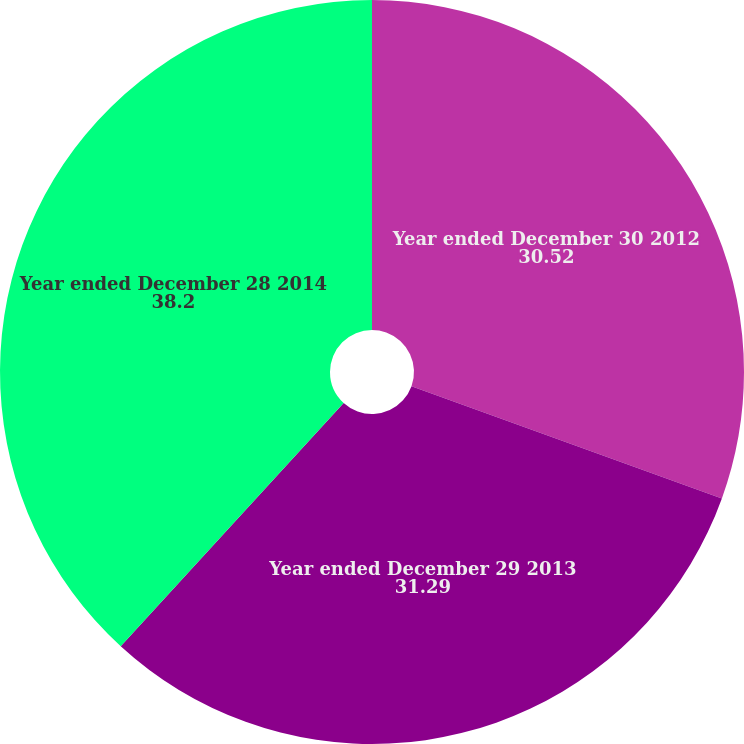Convert chart. <chart><loc_0><loc_0><loc_500><loc_500><pie_chart><fcel>Year ended December 30 2012<fcel>Year ended December 29 2013<fcel>Year ended December 28 2014<nl><fcel>30.52%<fcel>31.29%<fcel>38.2%<nl></chart> 